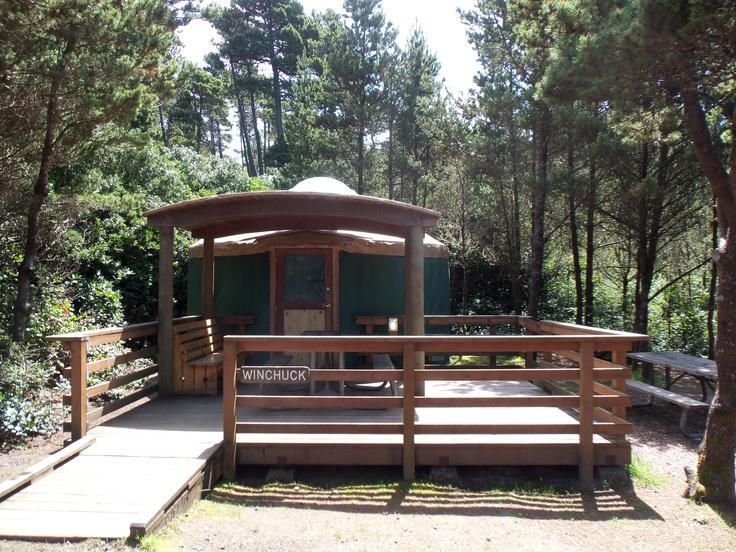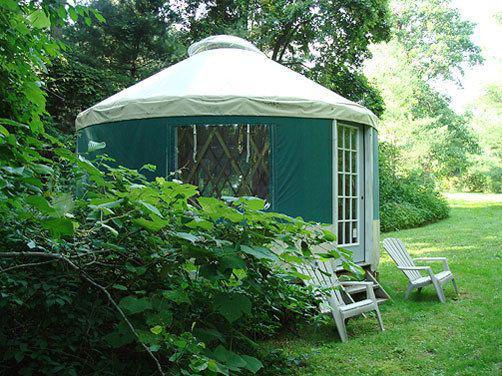The first image is the image on the left, the second image is the image on the right. Examine the images to the left and right. Is the description "At least one image shows a circular home with green exterior 'walls'." accurate? Answer yes or no. Yes. The first image is the image on the left, the second image is the image on the right. Considering the images on both sides, is "Two round houses are dark teal green with light colored conical roofs." valid? Answer yes or no. Yes. 